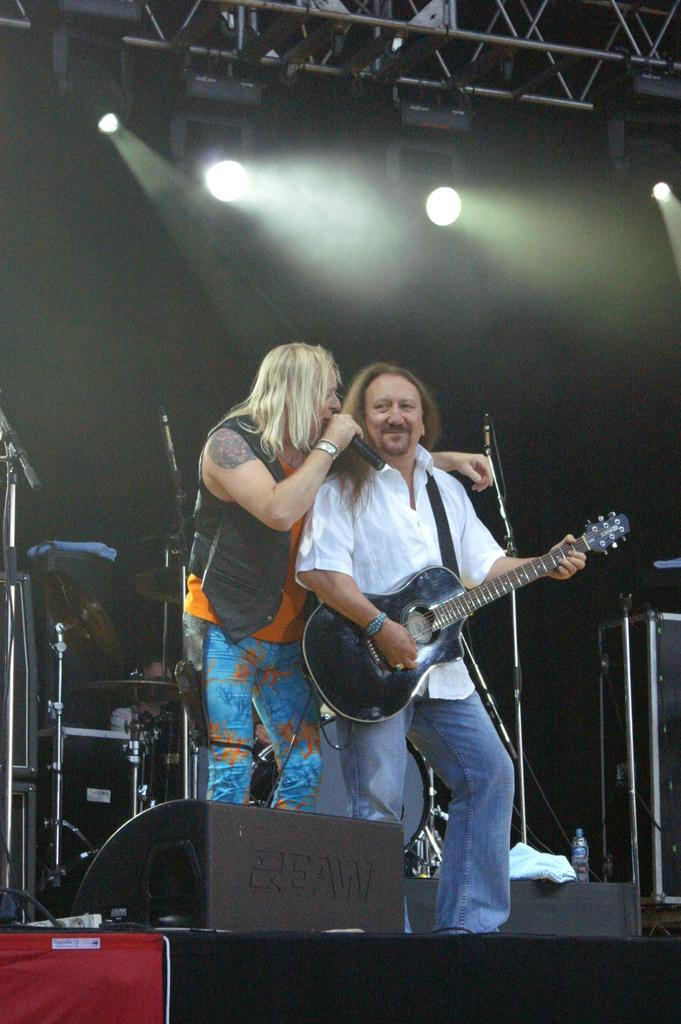What is happening in the image? There are two people on stage in the image. What are the two people holding in their hands? One man is holding a microphone in his hand, and the other man is holding a guitar in his hand. What type of lettuce is being used as a prop by the man holding the guitar? There is no lettuce present in the image; the man is holding a guitar. 